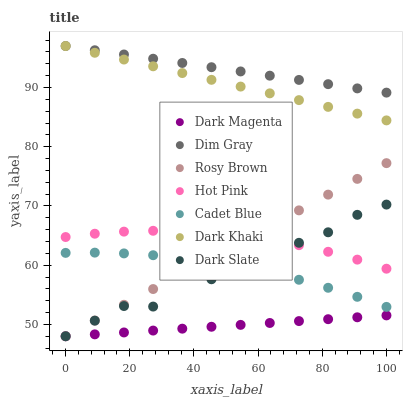Does Dark Magenta have the minimum area under the curve?
Answer yes or no. Yes. Does Dim Gray have the maximum area under the curve?
Answer yes or no. Yes. Does Rosy Brown have the minimum area under the curve?
Answer yes or no. No. Does Rosy Brown have the maximum area under the curve?
Answer yes or no. No. Is Dark Khaki the smoothest?
Answer yes or no. Yes. Is Dark Slate the roughest?
Answer yes or no. Yes. Is Dark Magenta the smoothest?
Answer yes or no. No. Is Dark Magenta the roughest?
Answer yes or no. No. Does Dark Magenta have the lowest value?
Answer yes or no. Yes. Does Dark Khaki have the lowest value?
Answer yes or no. No. Does Dim Gray have the highest value?
Answer yes or no. Yes. Does Rosy Brown have the highest value?
Answer yes or no. No. Is Dark Magenta less than Dim Gray?
Answer yes or no. Yes. Is Dark Khaki greater than Dark Slate?
Answer yes or no. Yes. Does Rosy Brown intersect Cadet Blue?
Answer yes or no. Yes. Is Rosy Brown less than Cadet Blue?
Answer yes or no. No. Is Rosy Brown greater than Cadet Blue?
Answer yes or no. No. Does Dark Magenta intersect Dim Gray?
Answer yes or no. No. 